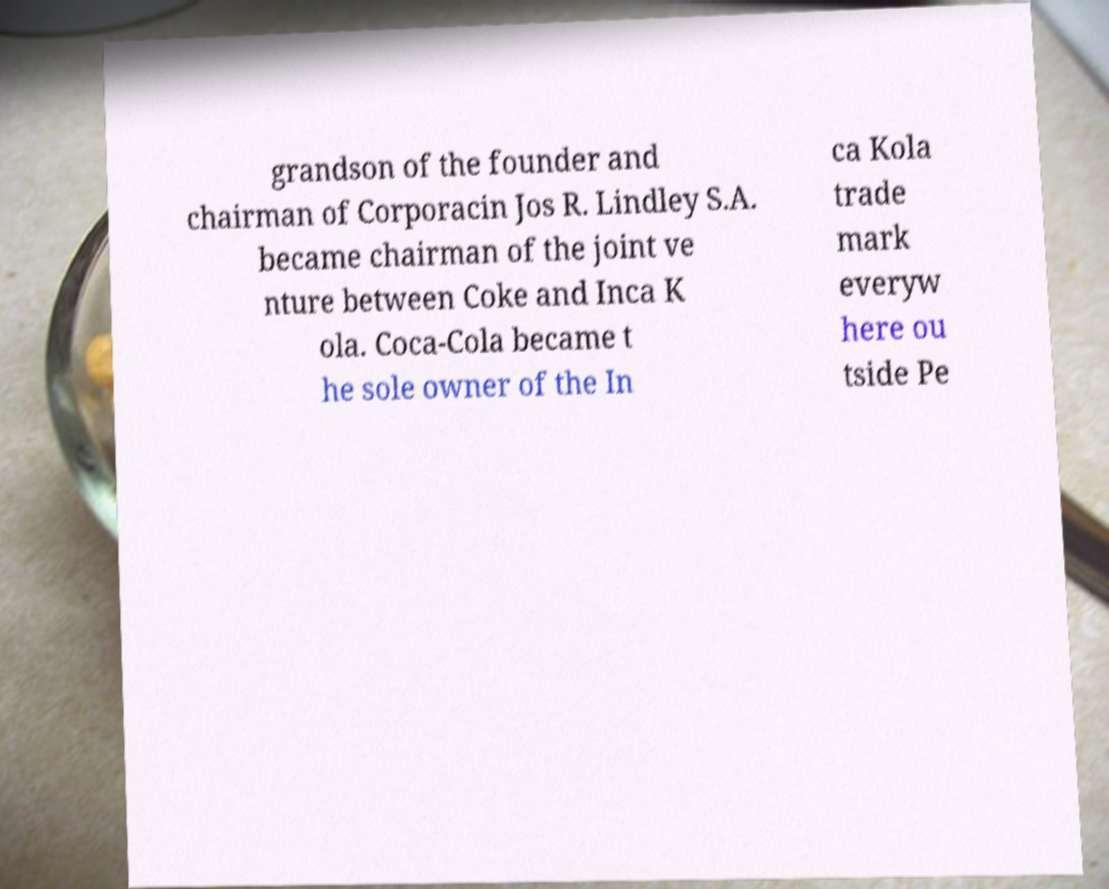What messages or text are displayed in this image? I need them in a readable, typed format. grandson of the founder and chairman of Corporacin Jos R. Lindley S.A. became chairman of the joint ve nture between Coke and Inca K ola. Coca-Cola became t he sole owner of the In ca Kola trade mark everyw here ou tside Pe 